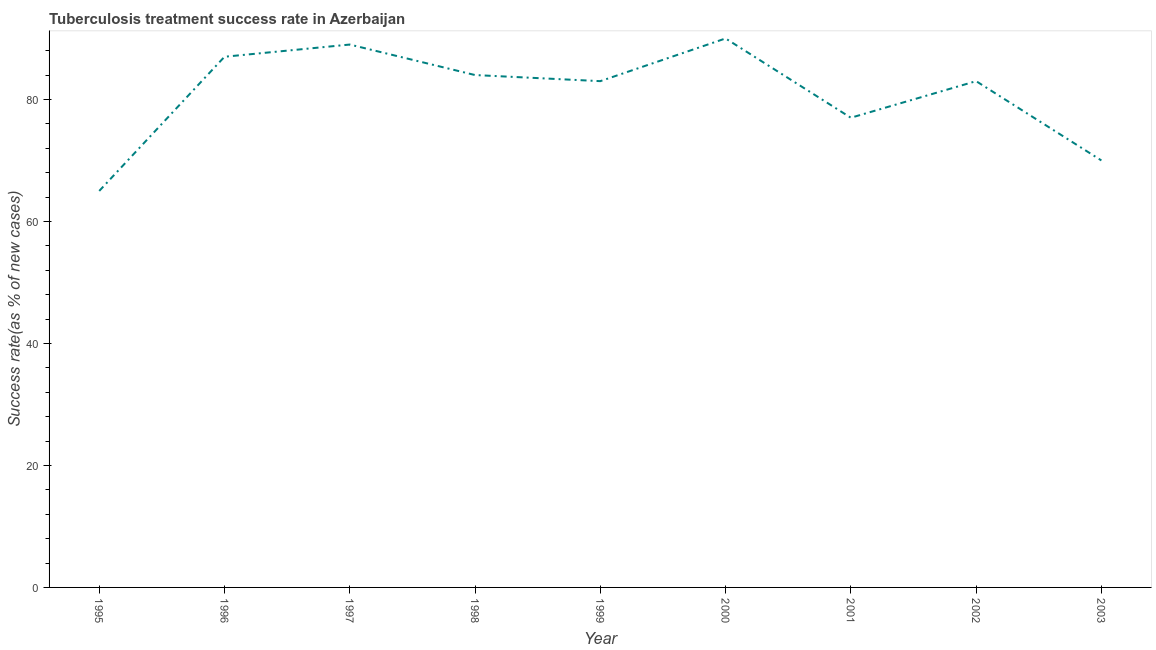What is the tuberculosis treatment success rate in 2000?
Offer a terse response. 90. Across all years, what is the maximum tuberculosis treatment success rate?
Make the answer very short. 90. Across all years, what is the minimum tuberculosis treatment success rate?
Your answer should be very brief. 65. In which year was the tuberculosis treatment success rate maximum?
Make the answer very short. 2000. What is the sum of the tuberculosis treatment success rate?
Ensure brevity in your answer.  728. What is the difference between the tuberculosis treatment success rate in 1995 and 1998?
Make the answer very short. -19. What is the average tuberculosis treatment success rate per year?
Provide a short and direct response. 80.89. Do a majority of the years between 1998 and 2003 (inclusive) have tuberculosis treatment success rate greater than 72 %?
Your answer should be very brief. Yes. What is the ratio of the tuberculosis treatment success rate in 1995 to that in 2000?
Your response must be concise. 0.72. Is the difference between the tuberculosis treatment success rate in 1995 and 1999 greater than the difference between any two years?
Your answer should be very brief. No. What is the difference between the highest and the lowest tuberculosis treatment success rate?
Your response must be concise. 25. Does the tuberculosis treatment success rate monotonically increase over the years?
Offer a terse response. No. How many lines are there?
Give a very brief answer. 1. What is the difference between two consecutive major ticks on the Y-axis?
Make the answer very short. 20. What is the title of the graph?
Your answer should be compact. Tuberculosis treatment success rate in Azerbaijan. What is the label or title of the X-axis?
Give a very brief answer. Year. What is the label or title of the Y-axis?
Ensure brevity in your answer.  Success rate(as % of new cases). What is the Success rate(as % of new cases) in 1996?
Make the answer very short. 87. What is the Success rate(as % of new cases) in 1997?
Keep it short and to the point. 89. What is the Success rate(as % of new cases) of 2000?
Provide a succinct answer. 90. What is the Success rate(as % of new cases) in 2001?
Keep it short and to the point. 77. What is the difference between the Success rate(as % of new cases) in 1995 and 1996?
Offer a terse response. -22. What is the difference between the Success rate(as % of new cases) in 1995 and 1997?
Make the answer very short. -24. What is the difference between the Success rate(as % of new cases) in 1995 and 1998?
Make the answer very short. -19. What is the difference between the Success rate(as % of new cases) in 1995 and 1999?
Your answer should be compact. -18. What is the difference between the Success rate(as % of new cases) in 1995 and 2001?
Make the answer very short. -12. What is the difference between the Success rate(as % of new cases) in 1995 and 2003?
Make the answer very short. -5. What is the difference between the Success rate(as % of new cases) in 1996 and 1997?
Your response must be concise. -2. What is the difference between the Success rate(as % of new cases) in 1996 and 1998?
Your answer should be compact. 3. What is the difference between the Success rate(as % of new cases) in 1996 and 1999?
Your response must be concise. 4. What is the difference between the Success rate(as % of new cases) in 1996 and 2002?
Your answer should be compact. 4. What is the difference between the Success rate(as % of new cases) in 1996 and 2003?
Offer a very short reply. 17. What is the difference between the Success rate(as % of new cases) in 1997 and 2000?
Offer a terse response. -1. What is the difference between the Success rate(as % of new cases) in 1997 and 2001?
Keep it short and to the point. 12. What is the difference between the Success rate(as % of new cases) in 1997 and 2002?
Ensure brevity in your answer.  6. What is the difference between the Success rate(as % of new cases) in 1998 and 2001?
Your answer should be compact. 7. What is the difference between the Success rate(as % of new cases) in 1998 and 2002?
Provide a short and direct response. 1. What is the difference between the Success rate(as % of new cases) in 1999 and 2002?
Your response must be concise. 0. What is the difference between the Success rate(as % of new cases) in 2000 and 2002?
Provide a succinct answer. 7. What is the difference between the Success rate(as % of new cases) in 2001 and 2002?
Offer a very short reply. -6. What is the difference between the Success rate(as % of new cases) in 2001 and 2003?
Give a very brief answer. 7. What is the difference between the Success rate(as % of new cases) in 2002 and 2003?
Give a very brief answer. 13. What is the ratio of the Success rate(as % of new cases) in 1995 to that in 1996?
Offer a terse response. 0.75. What is the ratio of the Success rate(as % of new cases) in 1995 to that in 1997?
Your answer should be compact. 0.73. What is the ratio of the Success rate(as % of new cases) in 1995 to that in 1998?
Your response must be concise. 0.77. What is the ratio of the Success rate(as % of new cases) in 1995 to that in 1999?
Provide a short and direct response. 0.78. What is the ratio of the Success rate(as % of new cases) in 1995 to that in 2000?
Ensure brevity in your answer.  0.72. What is the ratio of the Success rate(as % of new cases) in 1995 to that in 2001?
Offer a very short reply. 0.84. What is the ratio of the Success rate(as % of new cases) in 1995 to that in 2002?
Provide a succinct answer. 0.78. What is the ratio of the Success rate(as % of new cases) in 1995 to that in 2003?
Your response must be concise. 0.93. What is the ratio of the Success rate(as % of new cases) in 1996 to that in 1998?
Offer a very short reply. 1.04. What is the ratio of the Success rate(as % of new cases) in 1996 to that in 1999?
Your answer should be very brief. 1.05. What is the ratio of the Success rate(as % of new cases) in 1996 to that in 2001?
Provide a short and direct response. 1.13. What is the ratio of the Success rate(as % of new cases) in 1996 to that in 2002?
Your response must be concise. 1.05. What is the ratio of the Success rate(as % of new cases) in 1996 to that in 2003?
Your answer should be very brief. 1.24. What is the ratio of the Success rate(as % of new cases) in 1997 to that in 1998?
Your answer should be very brief. 1.06. What is the ratio of the Success rate(as % of new cases) in 1997 to that in 1999?
Offer a terse response. 1.07. What is the ratio of the Success rate(as % of new cases) in 1997 to that in 2000?
Offer a very short reply. 0.99. What is the ratio of the Success rate(as % of new cases) in 1997 to that in 2001?
Offer a terse response. 1.16. What is the ratio of the Success rate(as % of new cases) in 1997 to that in 2002?
Ensure brevity in your answer.  1.07. What is the ratio of the Success rate(as % of new cases) in 1997 to that in 2003?
Offer a very short reply. 1.27. What is the ratio of the Success rate(as % of new cases) in 1998 to that in 2000?
Ensure brevity in your answer.  0.93. What is the ratio of the Success rate(as % of new cases) in 1998 to that in 2001?
Your response must be concise. 1.09. What is the ratio of the Success rate(as % of new cases) in 1998 to that in 2002?
Offer a very short reply. 1.01. What is the ratio of the Success rate(as % of new cases) in 1998 to that in 2003?
Offer a terse response. 1.2. What is the ratio of the Success rate(as % of new cases) in 1999 to that in 2000?
Make the answer very short. 0.92. What is the ratio of the Success rate(as % of new cases) in 1999 to that in 2001?
Provide a short and direct response. 1.08. What is the ratio of the Success rate(as % of new cases) in 1999 to that in 2002?
Your response must be concise. 1. What is the ratio of the Success rate(as % of new cases) in 1999 to that in 2003?
Offer a terse response. 1.19. What is the ratio of the Success rate(as % of new cases) in 2000 to that in 2001?
Provide a succinct answer. 1.17. What is the ratio of the Success rate(as % of new cases) in 2000 to that in 2002?
Provide a succinct answer. 1.08. What is the ratio of the Success rate(as % of new cases) in 2000 to that in 2003?
Provide a succinct answer. 1.29. What is the ratio of the Success rate(as % of new cases) in 2001 to that in 2002?
Provide a short and direct response. 0.93. What is the ratio of the Success rate(as % of new cases) in 2002 to that in 2003?
Your response must be concise. 1.19. 